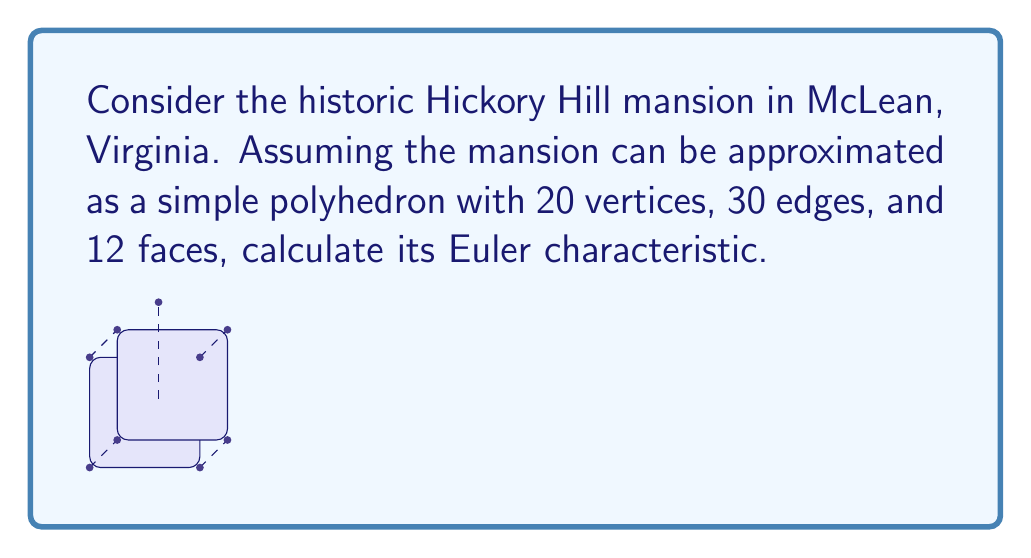Provide a solution to this math problem. To calculate the Euler characteristic of the Hickory Hill mansion approximation, we'll use the Euler formula for polyhedra:

$$\chi = V - E + F$$

Where:
$\chi$ = Euler characteristic
$V$ = Number of vertices
$E$ = Number of edges
$F$ = Number of faces

Given:
$V = 20$
$E = 30$
$F = 12$

Let's substitute these values into the formula:

$$\chi = 20 - 30 + 12$$

Now, let's perform the arithmetic:

$$\chi = 2$$

The Euler characteristic of 2 is consistent with the topological properties of a simple polyhedron homeomorphic to a sphere, which is what we would expect for a building-like structure.

This result tells us that, topologically, the simplified model of Hickory Hill mansion is equivalent to a sphere, regardless of its actual architectural complexity. The Euler characteristic is a topological invariant, meaning it remains constant under continuous deformations of the shape.
Answer: $\chi = 2$ 